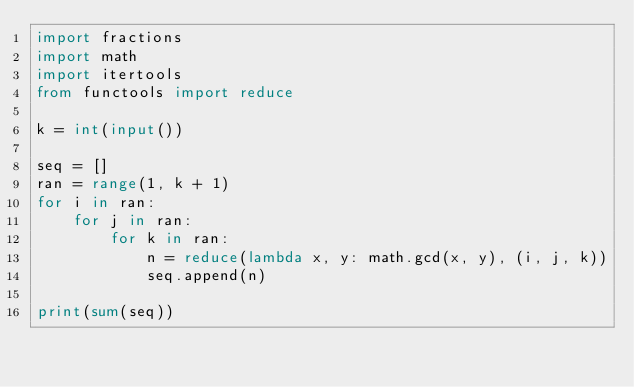Convert code to text. <code><loc_0><loc_0><loc_500><loc_500><_Python_>import fractions
import math
import itertools
from functools import reduce

k = int(input())

seq = []
ran = range(1, k + 1)
for i in ran:
    for j in ran:
        for k in ran:
            n = reduce(lambda x, y: math.gcd(x, y), (i, j, k))
            seq.append(n)

print(sum(seq))</code> 